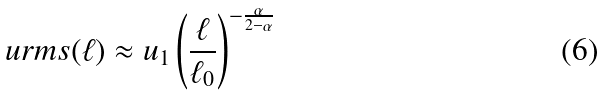<formula> <loc_0><loc_0><loc_500><loc_500>\ u r m s ( \ell ) \approx u _ { 1 } \left ( \frac { \ell } { \ell _ { 0 } } \right ) ^ { - \frac { \alpha } { 2 - \alpha } }</formula> 